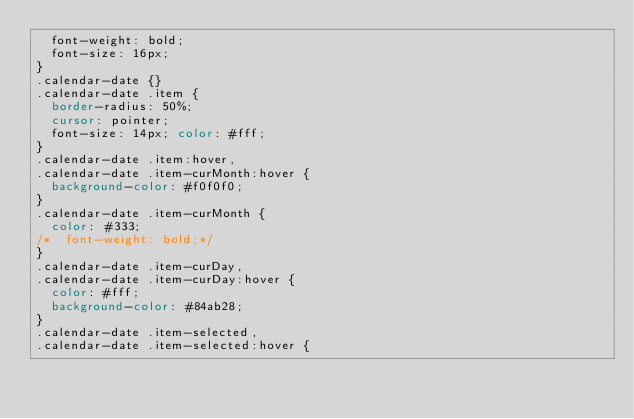<code> <loc_0><loc_0><loc_500><loc_500><_CSS_>  font-weight: bold;
  font-size: 16px;
}
.calendar-date {}
.calendar-date .item {
  border-radius: 50%;
  cursor: pointer;
  font-size: 14px; color: #fff;
}
.calendar-date .item:hover,
.calendar-date .item-curMonth:hover {
  background-color: #f0f0f0;
}
.calendar-date .item-curMonth {
  color: #333;
/*  font-weight: bold;*/
}
.calendar-date .item-curDay,
.calendar-date .item-curDay:hover {
  color: #fff;
  background-color: #84ab28;
}
.calendar-date .item-selected,
.calendar-date .item-selected:hover {</code> 